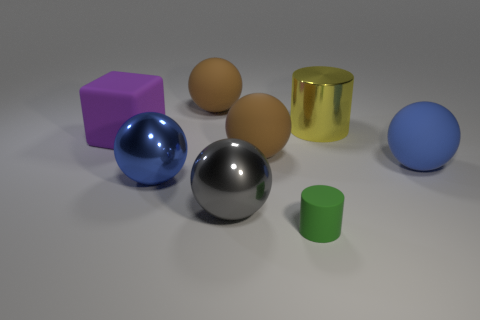Is the number of large matte balls that are on the right side of the tiny matte cylinder greater than the number of big yellow cylinders that are in front of the large yellow metal thing?
Provide a succinct answer. Yes. There is a large rubber cube that is to the left of the big cylinder; is it the same color as the rubber cylinder?
Keep it short and to the point. No. Are there any other things of the same color as the large cylinder?
Your response must be concise. No. Do the block and the blue matte ball have the same size?
Make the answer very short. Yes. There is a tiny thing that is the same shape as the large yellow thing; what is it made of?
Offer a terse response. Rubber. There is a large sphere that is behind the large matte block; what is its material?
Give a very brief answer. Rubber. Does the big gray object that is on the left side of the big yellow shiny thing have the same shape as the big yellow object?
Your answer should be very brief. No. How many big matte things are to the right of the large yellow object and on the left side of the large gray sphere?
Give a very brief answer. 0. What color is the big ball that is to the left of the rubber sphere that is behind the block?
Offer a very short reply. Blue. Does the blue matte object have the same shape as the large blue thing on the left side of the tiny object?
Your answer should be very brief. Yes. 